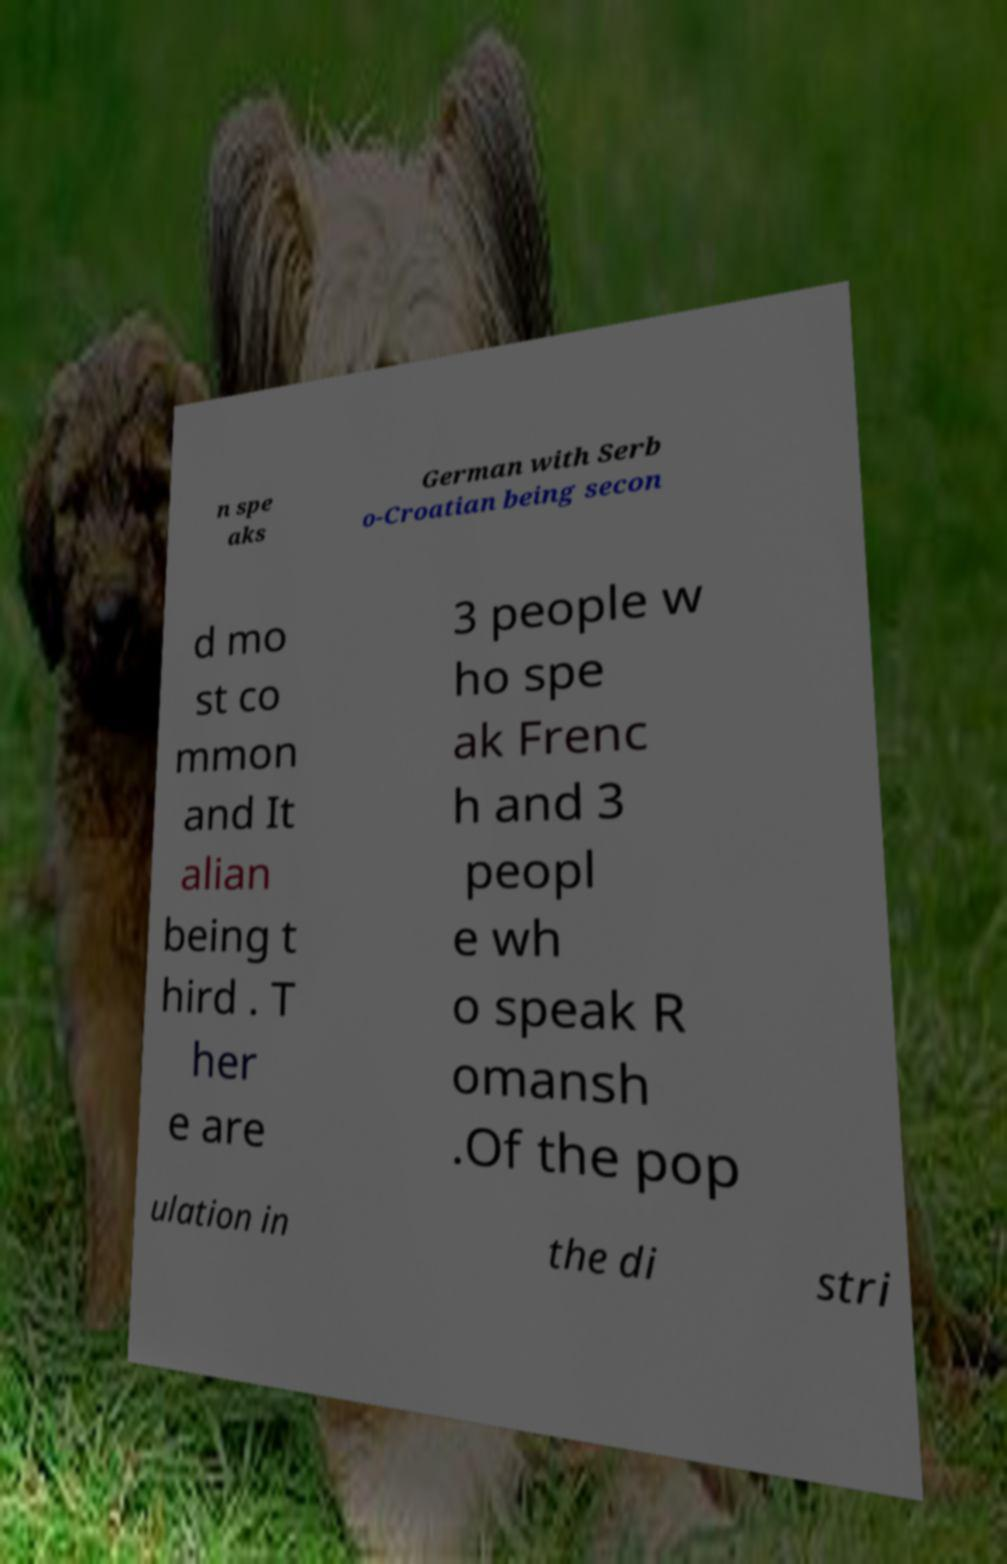There's text embedded in this image that I need extracted. Can you transcribe it verbatim? n spe aks German with Serb o-Croatian being secon d mo st co mmon and It alian being t hird . T her e are 3 people w ho spe ak Frenc h and 3 peopl e wh o speak R omansh .Of the pop ulation in the di stri 